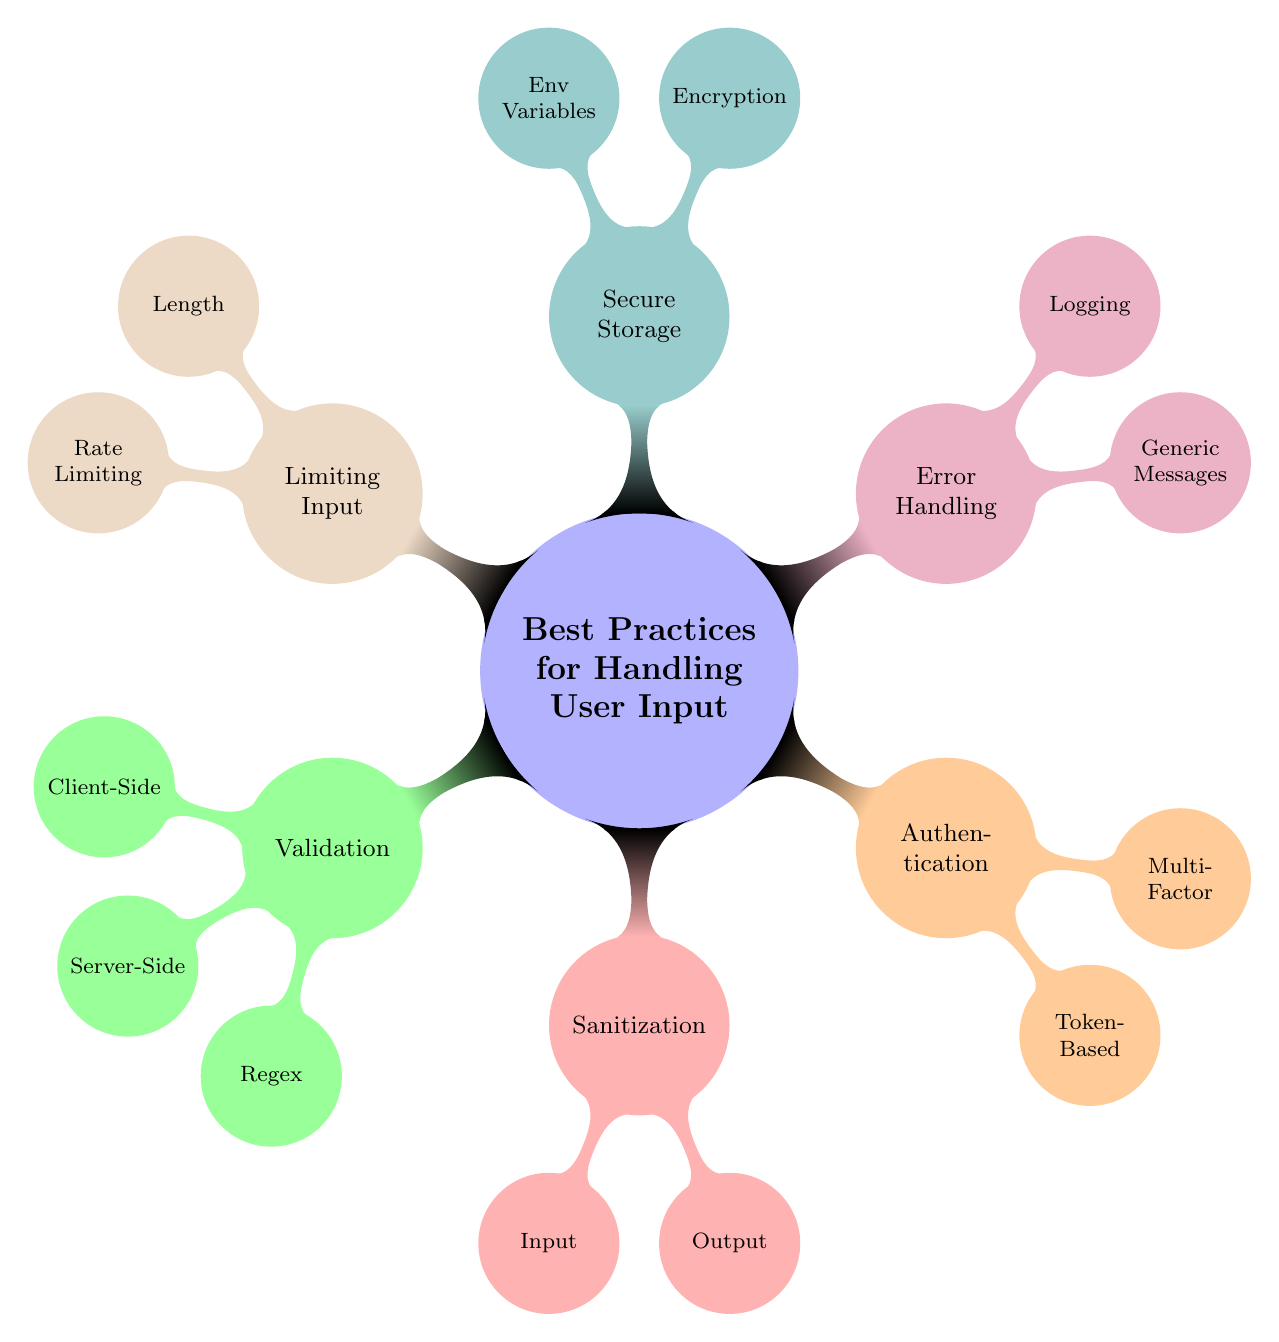What are the main categories in the diagram? The main categories are located directly under the root node "Best Practices for Handling User Input." They include Validation, Sanitization, Authentication, Error Handling, Secure Storage, and Limiting Input.
Answer: Validation, Sanitization, Authentication, Error Handling, Secure Storage, Limiting Input How many nodes are present in the Validation category? The Validation category has three child nodes directly beneath it: Client-Side, Server-Side, and Regex. Counting these provides the total number of nodes in this category.
Answer: 3 Which category includes Multi-Factor Authentication? The Multi-Factor Authentication node is a child of the Authentication category. By stepping through the diagram, you can identify the relation between Multi-Factor Authentication and its parent category.
Answer: Authentication What is the second line of defense after Client-Side Validation? The second line of defense is described in the Server-Side Validation node, which stresses the need for server-side checks. To find this, you look for the details under the Validation category specifically mentioning Server-Side checks.
Answer: Server-Side Validation What does the Input Sanitization node aim to prevent? The Input Sanitization node focuses on removing hazardous characters to prevent injection attacks. By examining the description of this node, the intended prevention goal becomes clear.
Answer: Injection attacks What is the purpose of Logging in Error Handling? The Logging node specifies that its purpose is "Log errors securely on the server." This emphasizes secure logging as a part of effective error handling, which can be found directly under the Error Handling category.
Answer: Secure logging How many nodes are there in the Secure Storage category? The Secure Storage category has two child nodes: Encryption and Environment Variables. Simply counting these child nodes reveals the total number of nodes under this category.
Answer: 2 Which practice is essential for preventing Cross-Site Scripting attacks? Output Encoding is critical for preventing XSS attacks. By locating the Output node within the Sanitization category, we confirm its importance in security practices against XSS.
Answer: Output Encoding How does Rate Limiting help in user input management? Rate Limiting helps in preventing abuse of input fields like login forms. This function is specified directly under the Limiting Input category, illustrating how it manages user input effectively.
Answer: Prevents abuse of input fields 